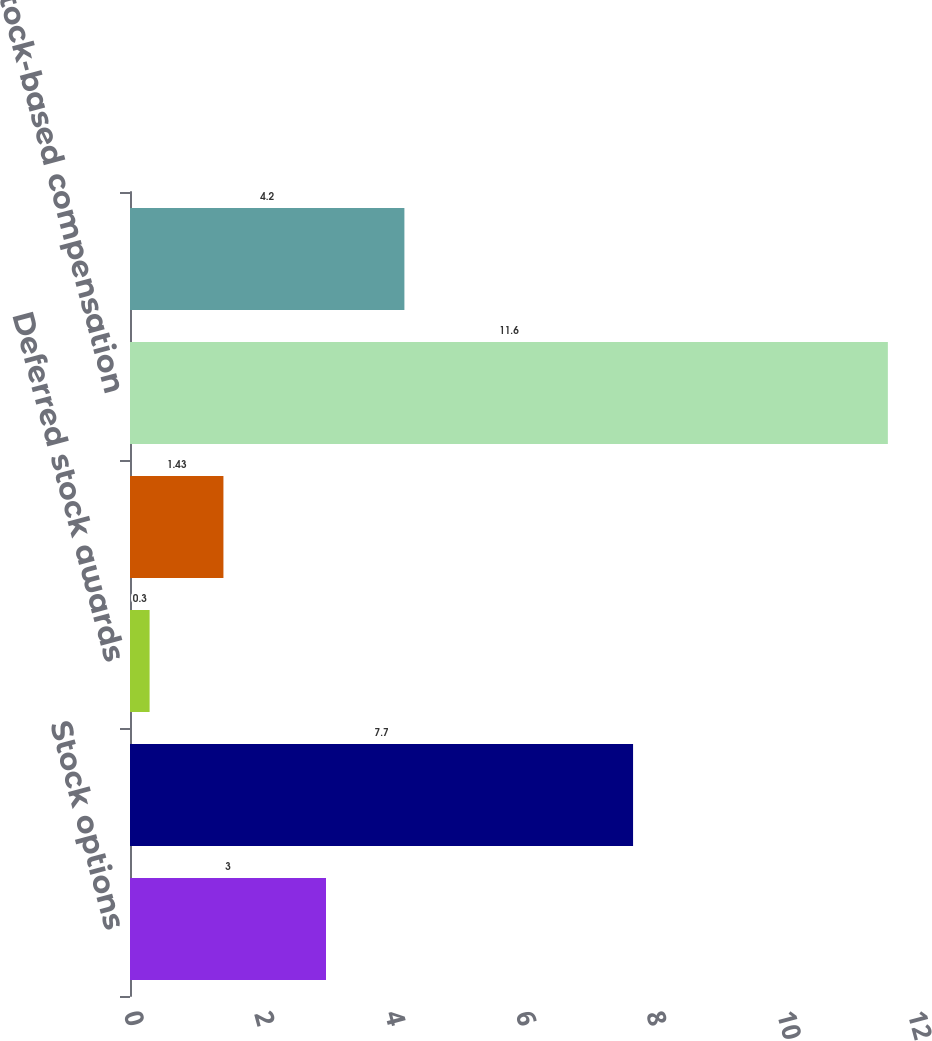<chart> <loc_0><loc_0><loc_500><loc_500><bar_chart><fcel>Stock options<fcel>Stock awards<fcel>Deferred stock awards<fcel>Employee stock purchase plan<fcel>Stock-based compensation<fcel>Tax benefit related to stock-<nl><fcel>3<fcel>7.7<fcel>0.3<fcel>1.43<fcel>11.6<fcel>4.2<nl></chart> 